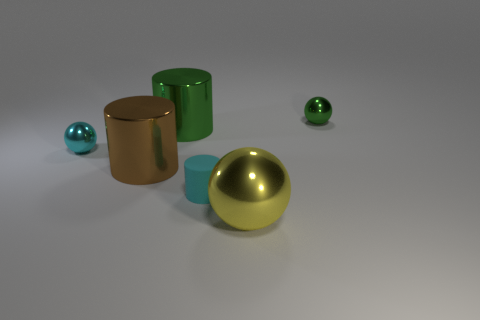Do the tiny matte cylinder and the shiny ball that is to the left of the cyan rubber cylinder have the same color? Yes, the tiny matte cylinder and the shiny ball to the left of the cyan rubber cylinder do indeed have the same color. Both objects share a golden hue, despite the differences in their materials and finishes. 